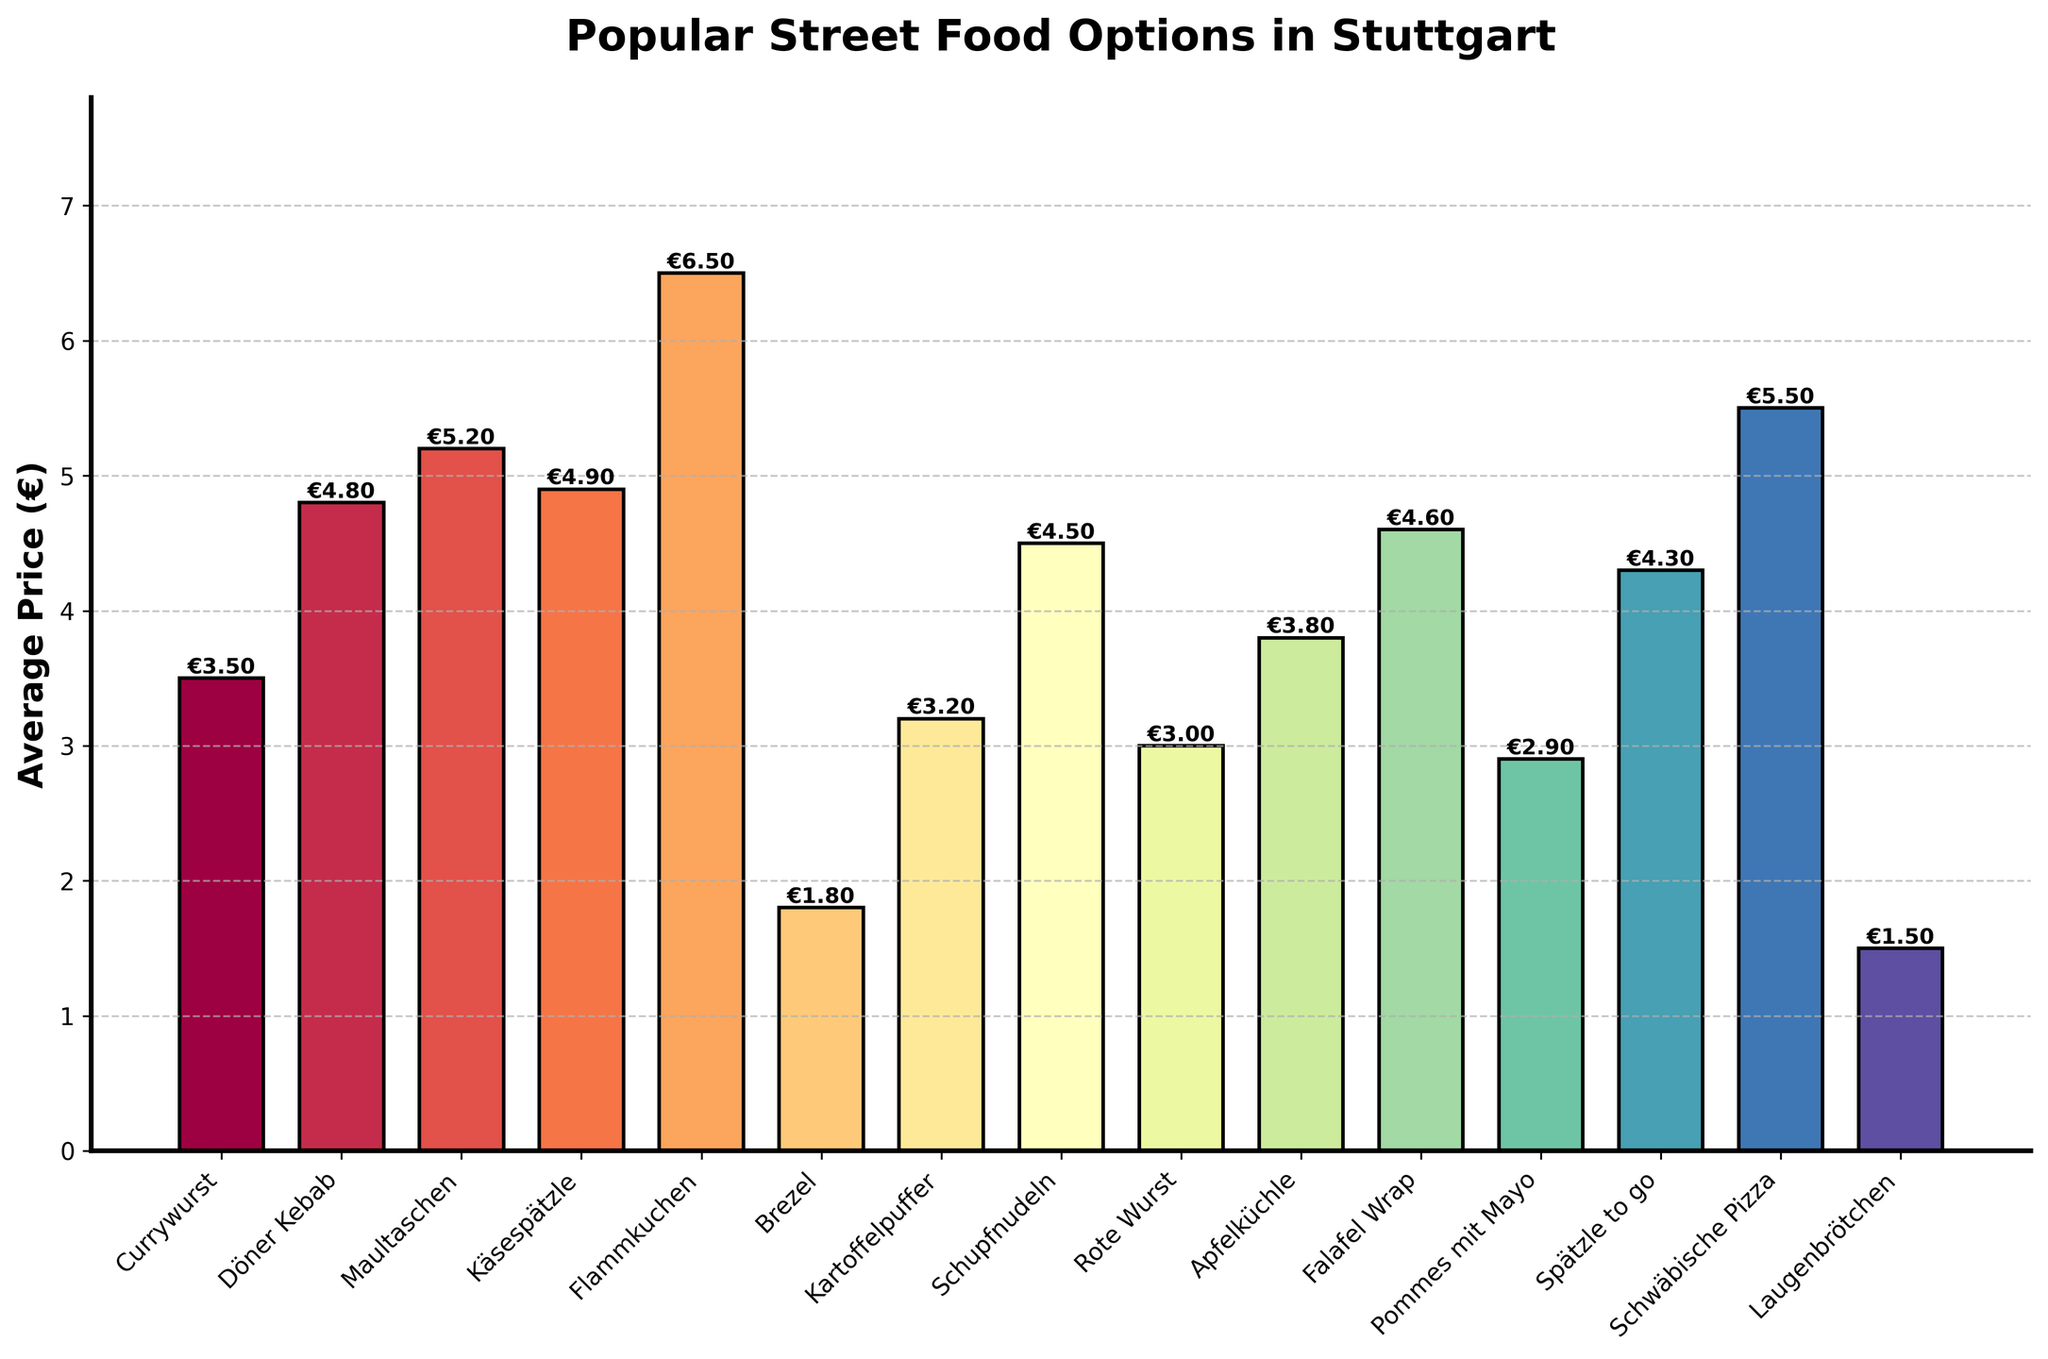Which street food option has the highest average price? To identify the highest average price, look for the tallest bar in the chart. Flammkuchen has the highest average price at €6.50.
Answer: Flammkuchen What is the average price of Brezel compared to Currywurst? Examine the heights of the Brezel and Currywurst bars. Brezel is €1.80, and Currywurst is €3.50, so Brezel is cheaper.
Answer: Brezel What is the total average price of Döner Kebab, Maultaschen, and Käsespätzle combined? Add the average prices of Döner Kebab (€4.80), Maultaschen (€5.20), and Käsespätzle (€4.90). The total is 4.80 + 5.20 + 4.90 = €14.90.
Answer: €14.90 How much more expensive is Schwäbische Pizza compared to Laugenbrötchen? Look at the average prices of Schwäbische Pizza (€5.50) and Laugenbrötchen (€1.50). Subtract the lower price from the higher price: 5.50 - 1.50 = €4.00.
Answer: €4.00 What is the average price difference between the food options with the highest and lowest prices? Identify the highest price (Flammkuchen, €6.50) and lowest price (Laugenbrötchen, €1.50). Subtract the lowest from the highest: 6.50 - 1.50 = €5.00.
Answer: €5.00 Which food has a higher average price: Falafel Wrap or Spätzle to go? Compare the heights of the bars representing Falafel Wrap (€4.60) and Spätzle to go (€4.30). Falafel Wrap is higher.
Answer: Falafel Wrap What is the combined average price of Apfelküchle and Rote Wurst? Add the average prices of Apfelküchle (€3.80) and Rote Wurst (€3.00). The total is 3.80 + 3.00 = €6.80.
Answer: €6.80 Which street food is cheaper on average: Kartoffelpuffer or Pommes mit Mayo? Compare the average prices by referring to the heights of the bars. Kartoffelpuffer is €3.20, and Pommes mit Mayo is €2.90, so Pommes mit Mayo is cheaper.
Answer: Pommes mit Mayo How many street food options have an average price less than €3.00? Count the bars with heights representing a price less than €3.00. Brezel, Rote Wurst, Pommes mit Mayo, and Laugenbrötchen make up 4 options.
Answer: 4 What is the average price difference between Käsespätzle and Schupfnudeln? Subtract the average price of Schupfnudeln (€4.50) from Käsespätzle (€4.90). The difference is 4.90 - 4.50 = €0.40.
Answer: €0.40 